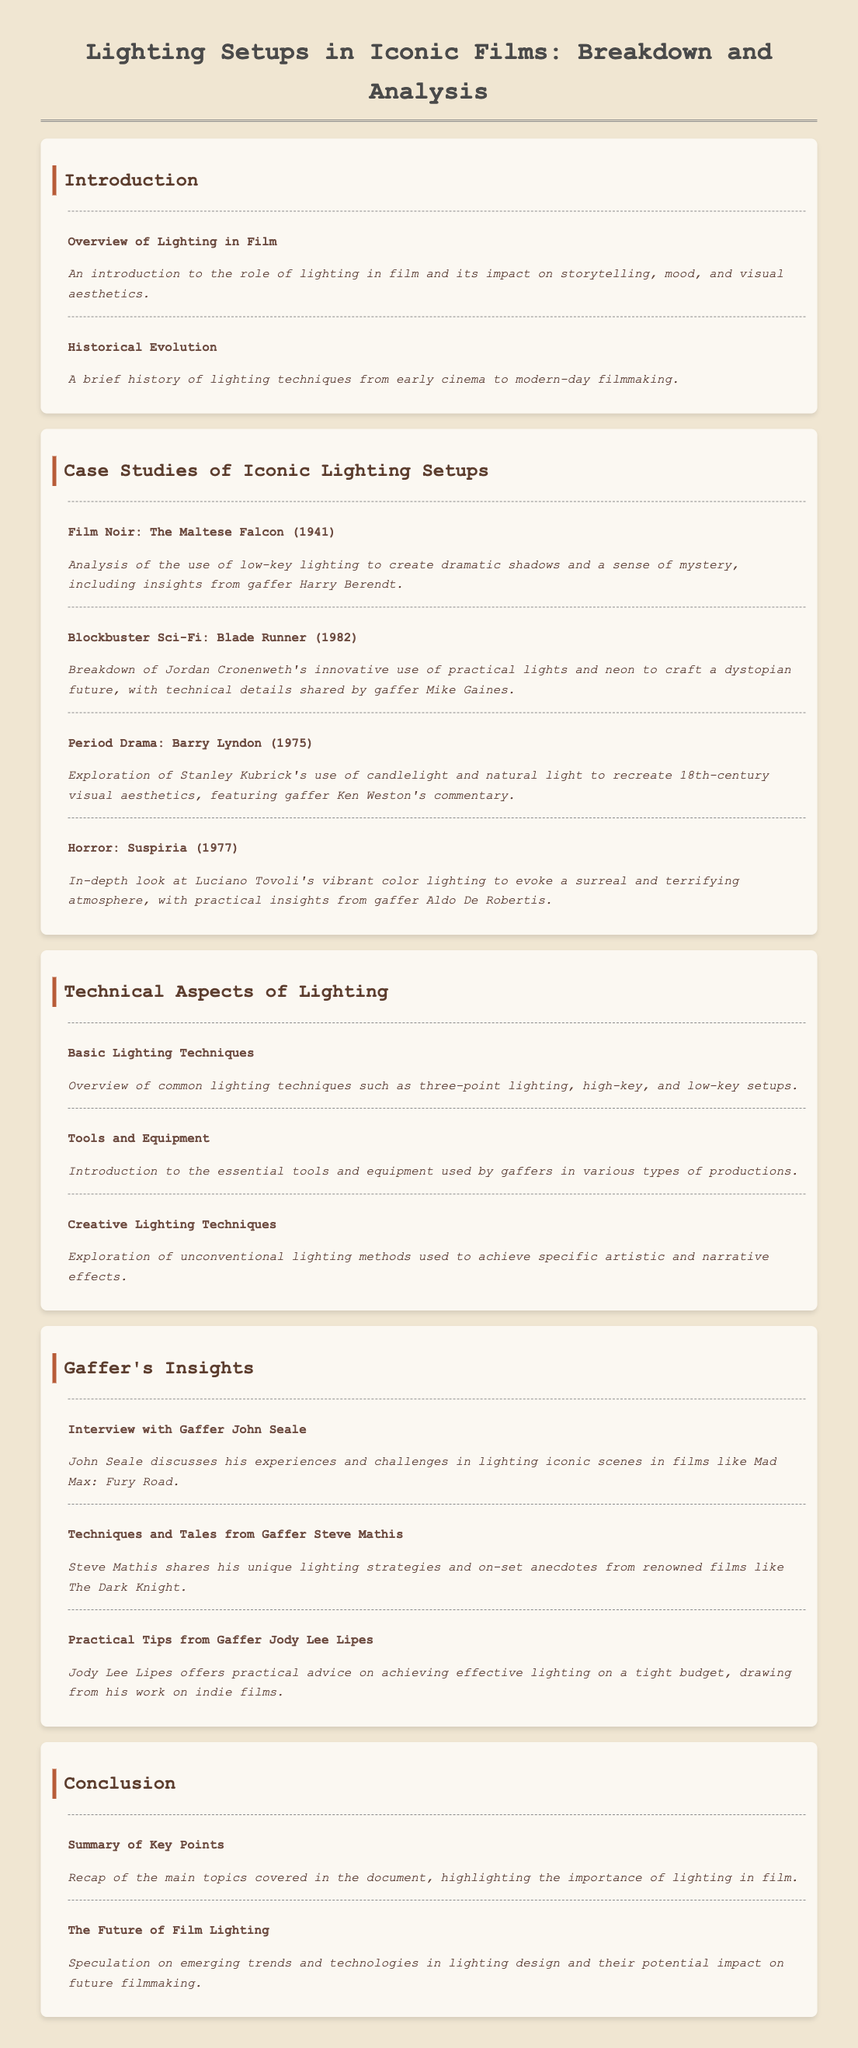What film is analyzed for its use of low-key lighting? The document mentions "The Maltese Falcon" as a case study for low-key lighting techniques.
Answer: The Maltese Falcon Who is the gaffer associated with "Blade Runner"? The document states that gaffer Mike Gaines provided technical details on "Blade Runner".
Answer: Mike Gaines How many case studies are presented in the document? The document lists four case studies of iconic films with unique lighting setups.
Answer: Four What year was "Barry Lyndon" released? The document specifies that "Barry Lyndon" was released in 1975.
Answer: 1975 Which section discusses practical tips from gaffers? The document has a subsection titled "Practical Tips from Gaffer Jody Lee Lipes" which focuses on practical advice for lighting.
Answer: Gaffer's Insights What lighting technique is mentioned as a common method? The document refers to "three-point lighting" as one of the basic lighting techniques.
Answer: Three-point lighting What is the main topic covered under the conclusion section? The conclusion section includes a recap of key points and emerging trends in lighting design.
Answer: Summary of Key Points Who discusses challenges faced in lighting "Mad Max: Fury Road"? The document features an interview with gaffer John Seale discussing his experiences.
Answer: John Seale 